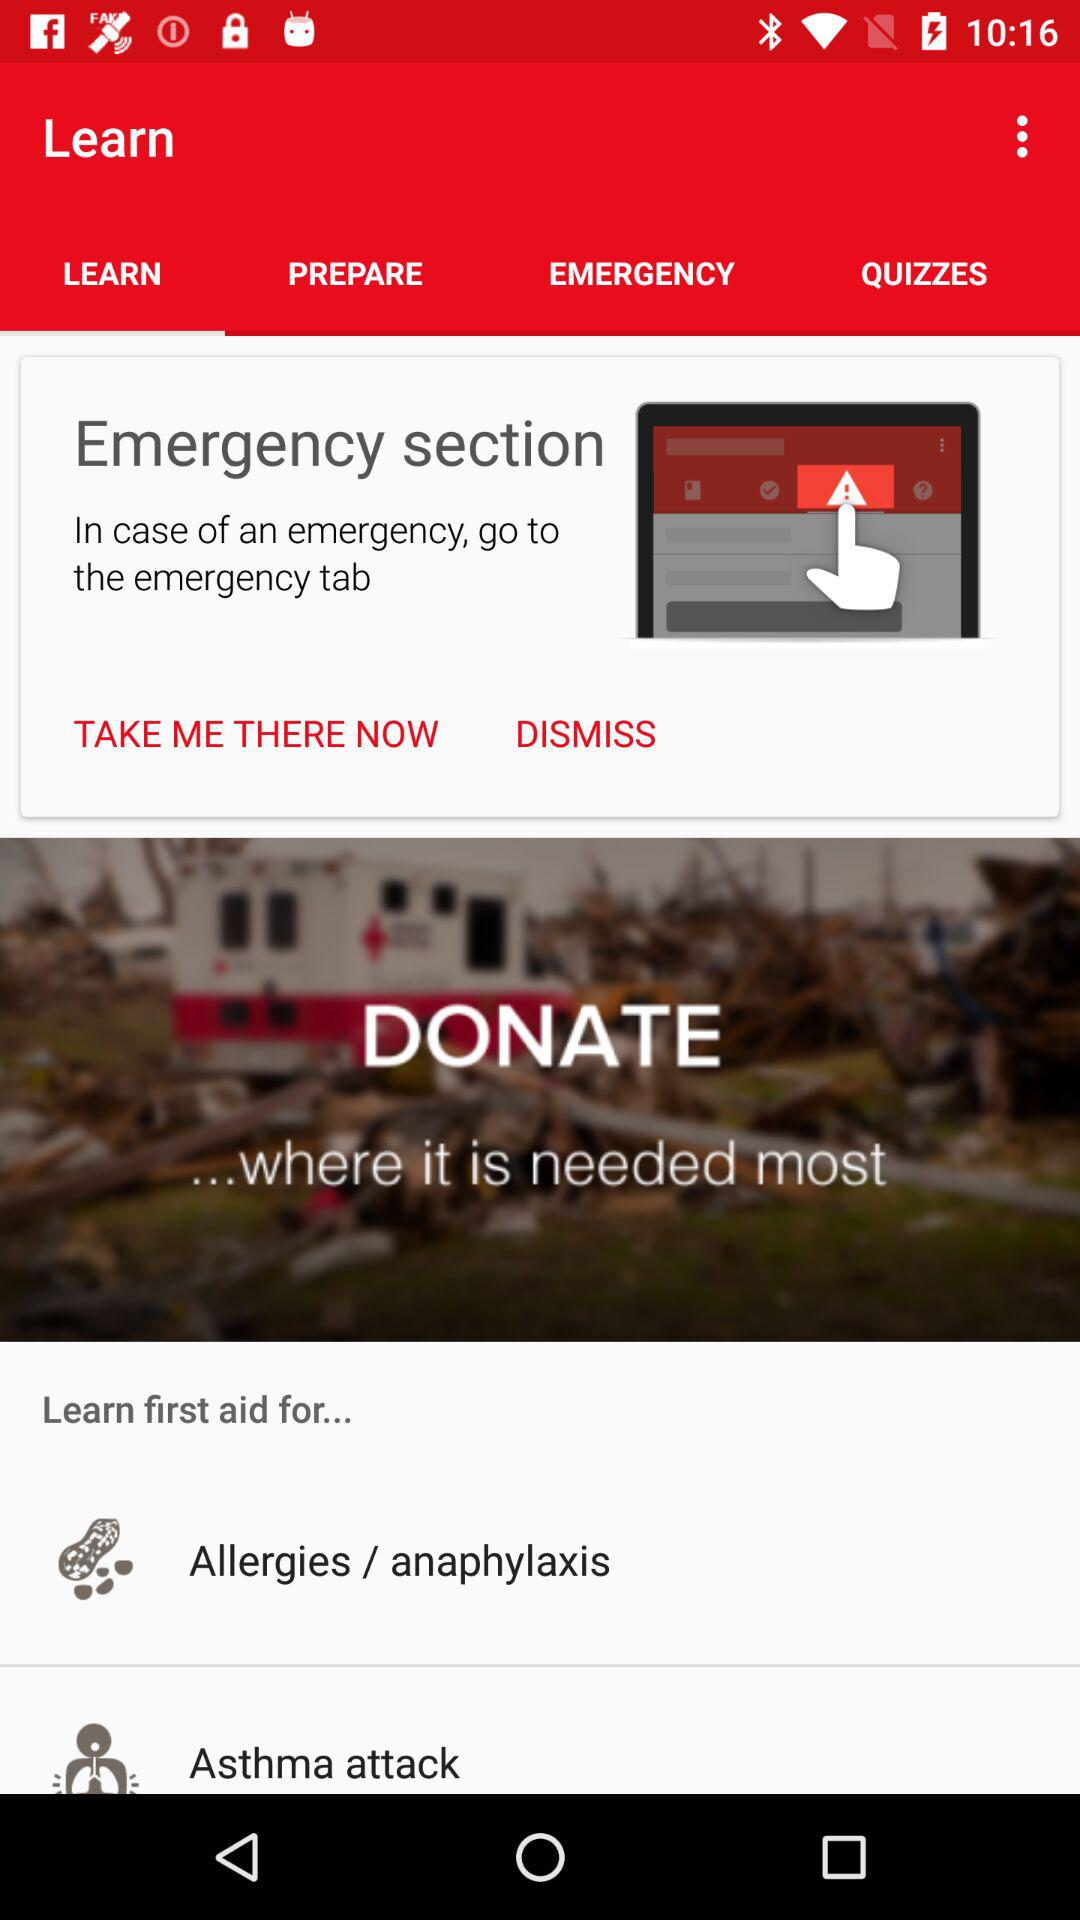To which tab do we need to go in case of an emergency? In case of an emergency, you need to go to the emergency tab. 